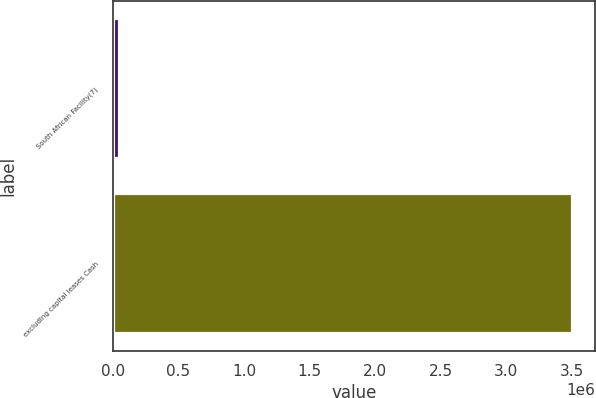Convert chart. <chart><loc_0><loc_0><loc_500><loc_500><bar_chart><fcel>South African Facility(7)<fcel>excluding capital leases Cash<nl><fcel>45241<fcel>3.50406e+06<nl></chart> 